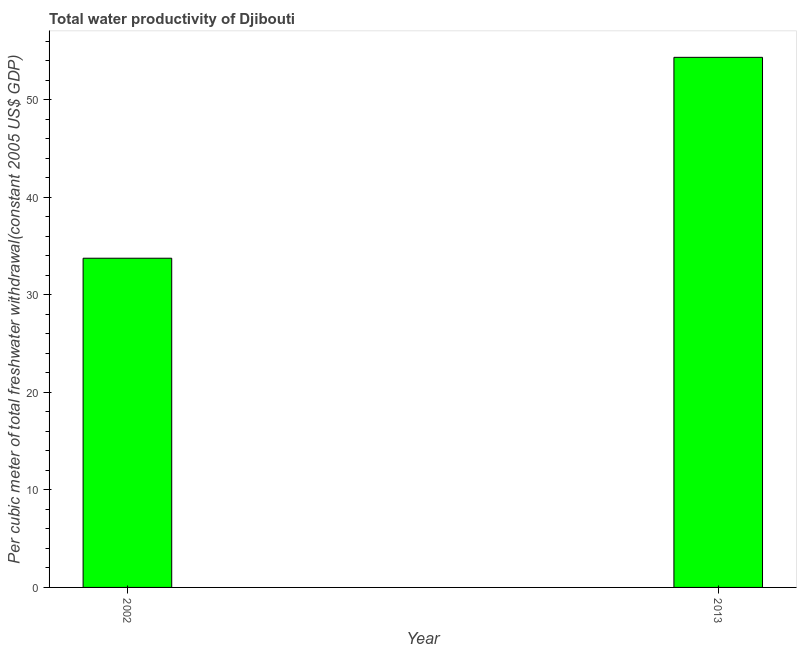What is the title of the graph?
Make the answer very short. Total water productivity of Djibouti. What is the label or title of the X-axis?
Provide a short and direct response. Year. What is the label or title of the Y-axis?
Offer a very short reply. Per cubic meter of total freshwater withdrawal(constant 2005 US$ GDP). What is the total water productivity in 2002?
Your answer should be very brief. 33.74. Across all years, what is the maximum total water productivity?
Your response must be concise. 54.33. Across all years, what is the minimum total water productivity?
Keep it short and to the point. 33.74. In which year was the total water productivity maximum?
Offer a very short reply. 2013. In which year was the total water productivity minimum?
Ensure brevity in your answer.  2002. What is the sum of the total water productivity?
Give a very brief answer. 88.07. What is the difference between the total water productivity in 2002 and 2013?
Ensure brevity in your answer.  -20.59. What is the average total water productivity per year?
Your response must be concise. 44.03. What is the median total water productivity?
Your answer should be very brief. 44.03. Do a majority of the years between 2002 and 2013 (inclusive) have total water productivity greater than 2 US$?
Offer a terse response. Yes. What is the ratio of the total water productivity in 2002 to that in 2013?
Ensure brevity in your answer.  0.62. How many bars are there?
Provide a short and direct response. 2. Are all the bars in the graph horizontal?
Offer a terse response. No. How many years are there in the graph?
Keep it short and to the point. 2. What is the difference between two consecutive major ticks on the Y-axis?
Make the answer very short. 10. Are the values on the major ticks of Y-axis written in scientific E-notation?
Your answer should be compact. No. What is the Per cubic meter of total freshwater withdrawal(constant 2005 US$ GDP) of 2002?
Provide a short and direct response. 33.74. What is the Per cubic meter of total freshwater withdrawal(constant 2005 US$ GDP) of 2013?
Give a very brief answer. 54.33. What is the difference between the Per cubic meter of total freshwater withdrawal(constant 2005 US$ GDP) in 2002 and 2013?
Make the answer very short. -20.59. What is the ratio of the Per cubic meter of total freshwater withdrawal(constant 2005 US$ GDP) in 2002 to that in 2013?
Give a very brief answer. 0.62. 